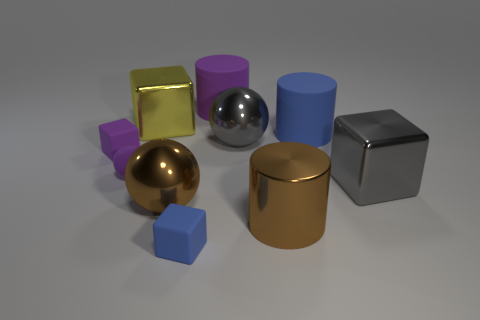Subtract all cubes. How many objects are left? 6 Add 4 gray blocks. How many gray blocks are left? 5 Add 5 large green metal cylinders. How many large green metal cylinders exist? 5 Subtract 0 gray cylinders. How many objects are left? 10 Subtract all small rubber objects. Subtract all large green cubes. How many objects are left? 7 